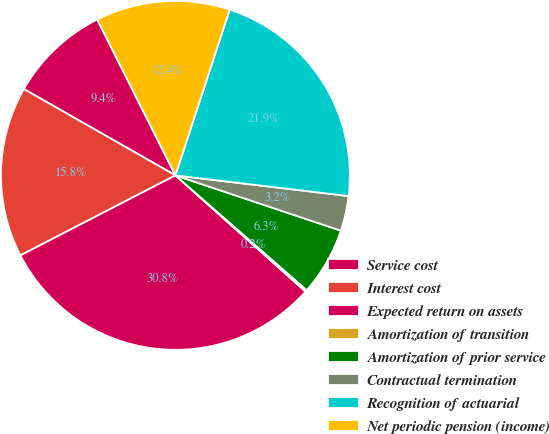Convert chart to OTSL. <chart><loc_0><loc_0><loc_500><loc_500><pie_chart><fcel>Service cost<fcel>Interest cost<fcel>Expected return on assets<fcel>Amortization of transition<fcel>Amortization of prior service<fcel>Contractual termination<fcel>Recognition of actuarial<fcel>Net periodic pension (income)<nl><fcel>9.36%<fcel>15.83%<fcel>30.81%<fcel>0.17%<fcel>6.3%<fcel>3.24%<fcel>21.86%<fcel>12.43%<nl></chart> 